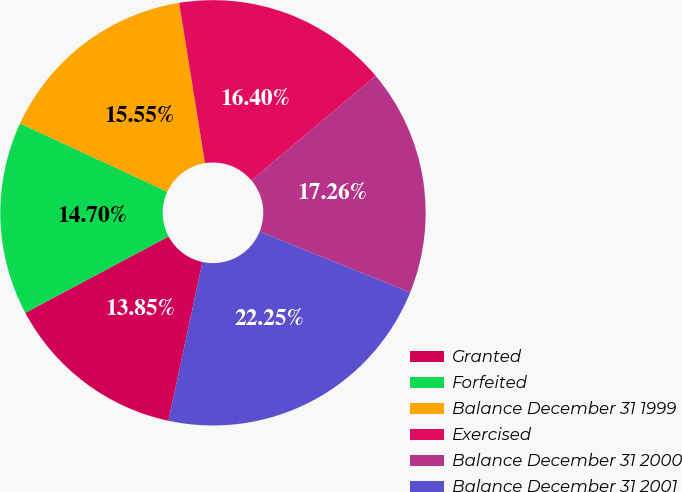<chart> <loc_0><loc_0><loc_500><loc_500><pie_chart><fcel>Granted<fcel>Forfeited<fcel>Balance December 31 1999<fcel>Exercised<fcel>Balance December 31 2000<fcel>Balance December 31 2001<nl><fcel>13.85%<fcel>14.7%<fcel>15.55%<fcel>16.4%<fcel>17.26%<fcel>22.25%<nl></chart> 